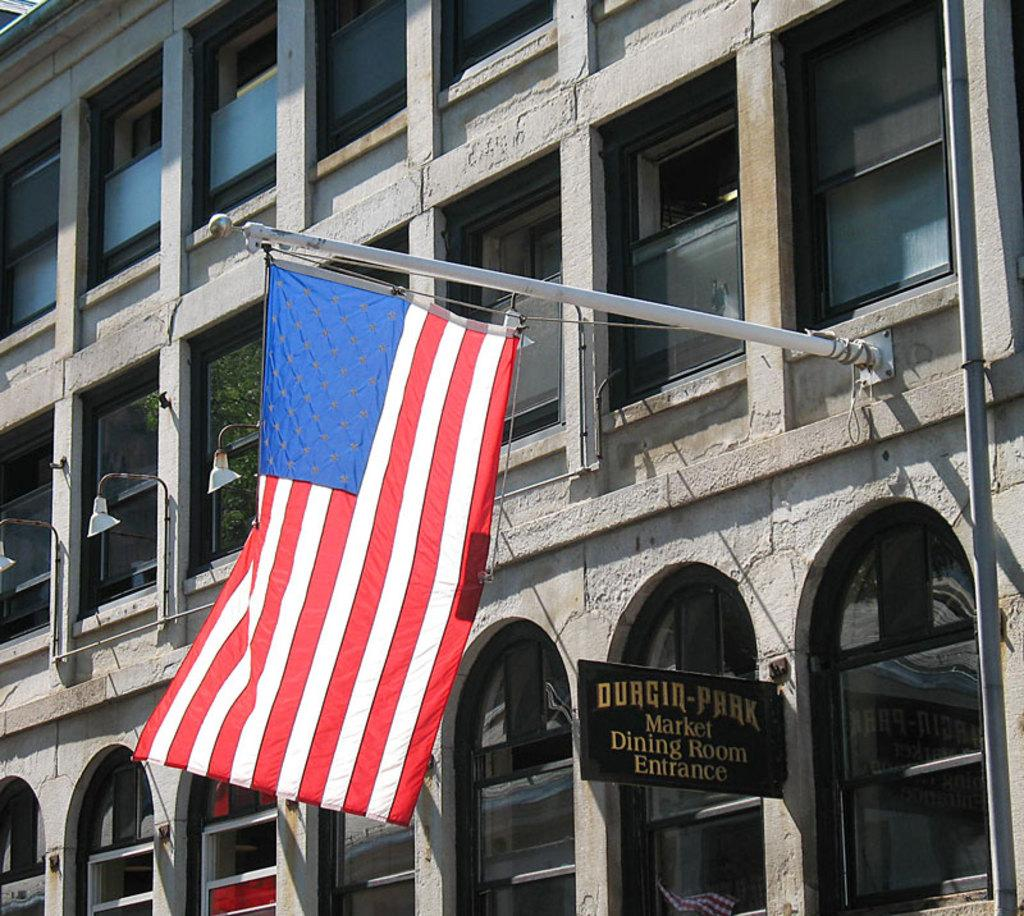What type of structure is present in the image? There is a building in the image. What feature of the building is mentioned in the facts? The building has multiple windows. What else can be seen in the image besides the building? There are lights, poles, a board, and a flag visible in the image. What is written on the board in the image? There is writing on the board in the image. Can you see any feathers floating around the building in the image? There are no feathers visible in the image. What type of house is depicted in the image? The image does not show a house; it features a building. 